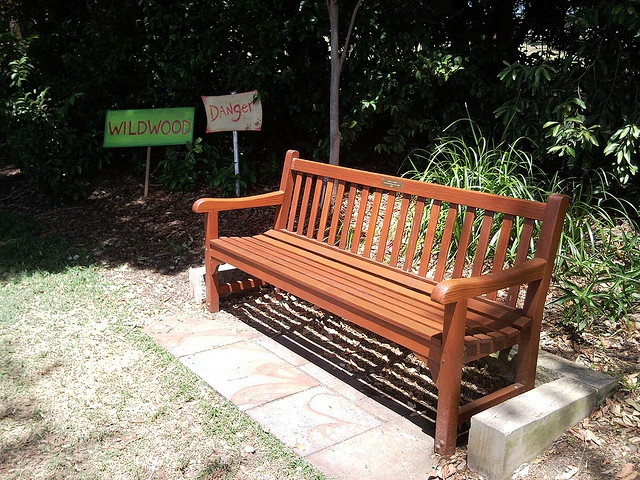Describe the objects in this image and their specific colors. I can see a bench in black, maroon, and salmon tones in this image. 